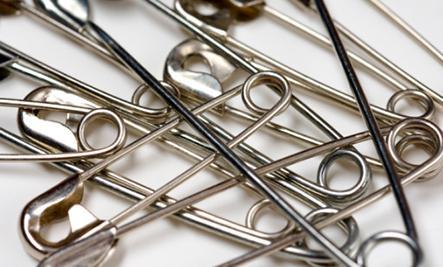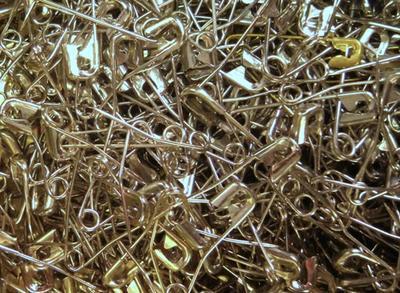The first image is the image on the left, the second image is the image on the right. Considering the images on both sides, is "An image shows one row of at least 10 unlinked safety pins." valid? Answer yes or no. No. The first image is the image on the left, the second image is the image on the right. Analyze the images presented: Is the assertion "In one image, safety pins are arranged from small to large and back to small sizes." valid? Answer yes or no. No. 